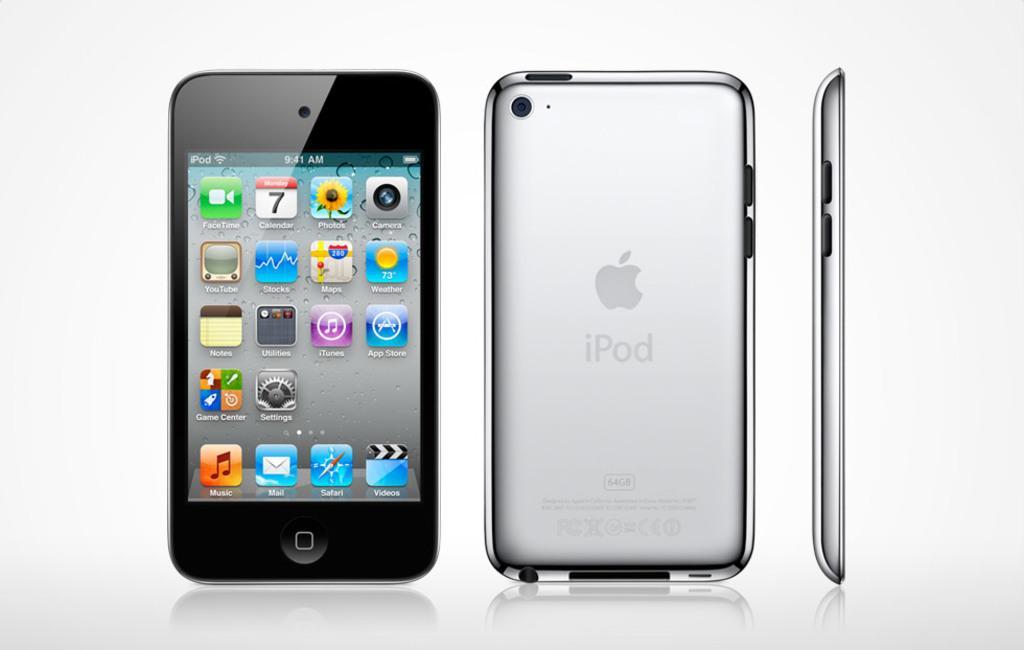How would you summarize this image in a sentence or two? In this picture, we see the front view, back view and the side view of the mobile phone. In the background, it is white in color. 